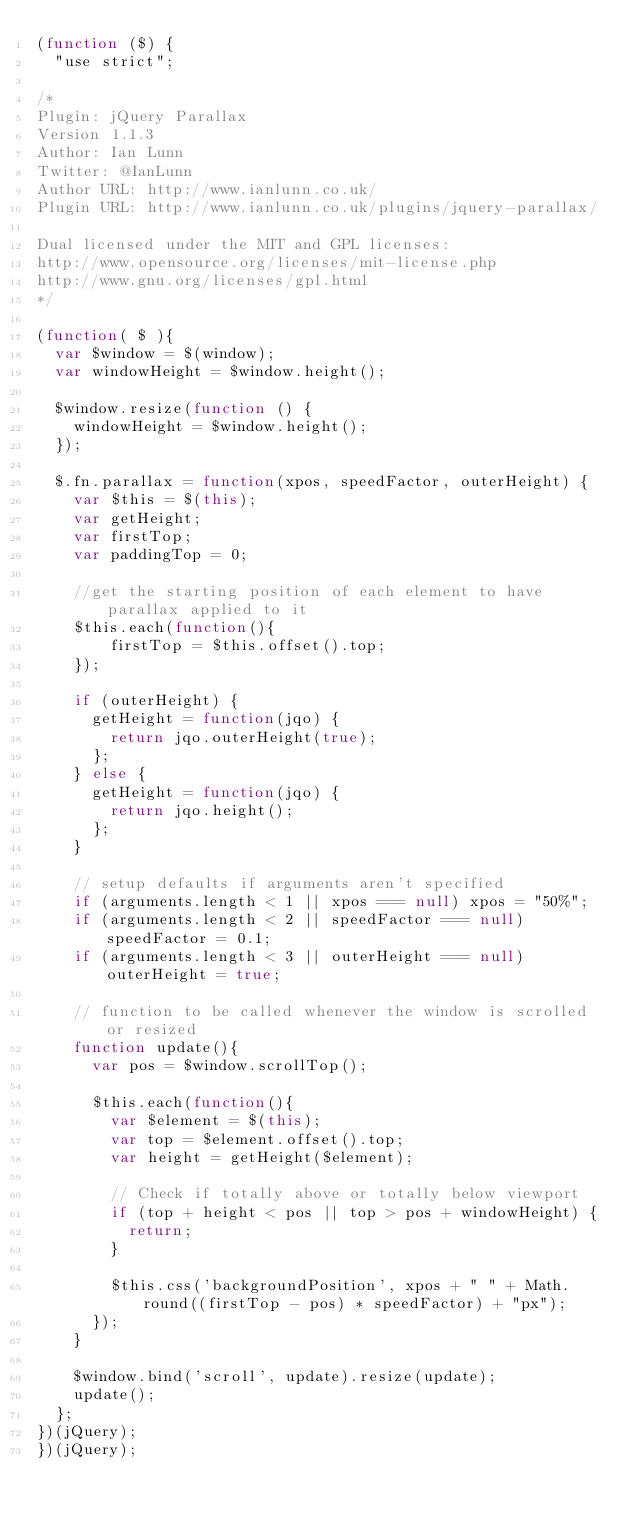<code> <loc_0><loc_0><loc_500><loc_500><_JavaScript_>(function ($) {
	"use strict";

/*
Plugin: jQuery Parallax
Version 1.1.3
Author: Ian Lunn
Twitter: @IanLunn
Author URL: http://www.ianlunn.co.uk/
Plugin URL: http://www.ianlunn.co.uk/plugins/jquery-parallax/

Dual licensed under the MIT and GPL licenses:
http://www.opensource.org/licenses/mit-license.php
http://www.gnu.org/licenses/gpl.html
*/

(function( $ ){
	var $window = $(window);
	var windowHeight = $window.height();

	$window.resize(function () {
		windowHeight = $window.height();
	});

	$.fn.parallax = function(xpos, speedFactor, outerHeight) {
		var $this = $(this);
		var getHeight;
		var firstTop;
		var paddingTop = 0;
		
		//get the starting position of each element to have parallax applied to it		
		$this.each(function(){
		    firstTop = $this.offset().top;
		});

		if (outerHeight) {
			getHeight = function(jqo) {
				return jqo.outerHeight(true);
			};
		} else {
			getHeight = function(jqo) {
				return jqo.height();
			};
		}
			
		// setup defaults if arguments aren't specified
		if (arguments.length < 1 || xpos === null) xpos = "50%";
		if (arguments.length < 2 || speedFactor === null) speedFactor = 0.1;
		if (arguments.length < 3 || outerHeight === null) outerHeight = true;
		
		// function to be called whenever the window is scrolled or resized
		function update(){
			var pos = $window.scrollTop();				

			$this.each(function(){
				var $element = $(this);
				var top = $element.offset().top;
				var height = getHeight($element);

				// Check if totally above or totally below viewport
				if (top + height < pos || top > pos + windowHeight) {
					return;
				}

				$this.css('backgroundPosition', xpos + " " + Math.round((firstTop - pos) * speedFactor) + "px");
			});
		}		

		$window.bind('scroll', update).resize(update);
		update();
	};
})(jQuery);
})(jQuery);
</code> 